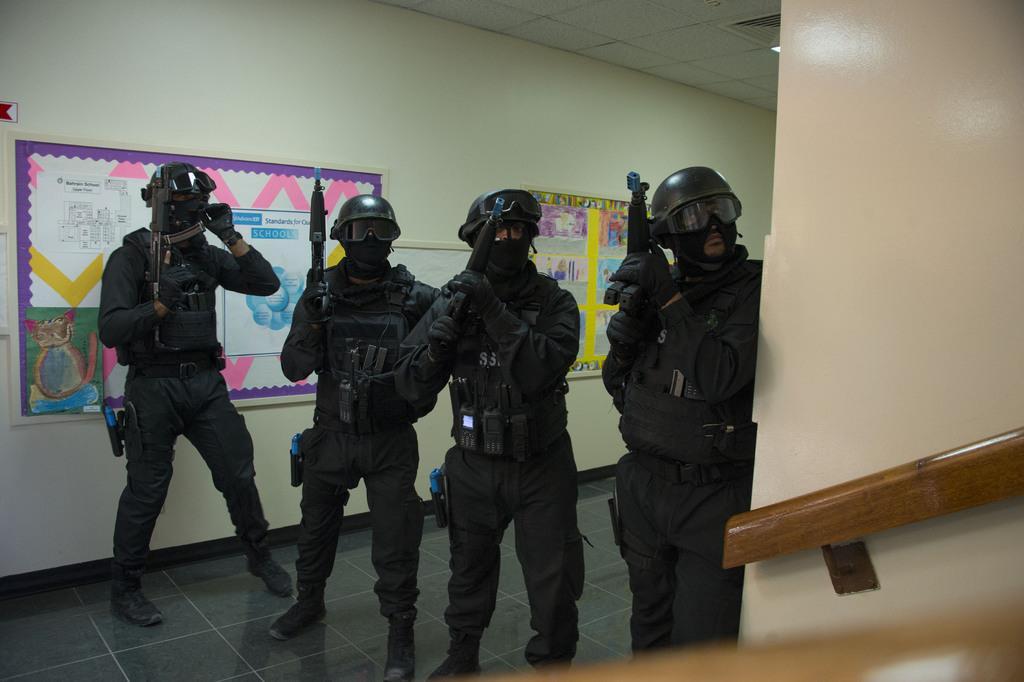In one or two sentences, can you explain what this image depicts? There are four people standing and holding weapons in their hands. I think they are soldiers. They wore a black color dress and shoes. These are the notice boards with papers on it. This looks like a wooden staircase holder, which is attached to the wall. This is the roof. 